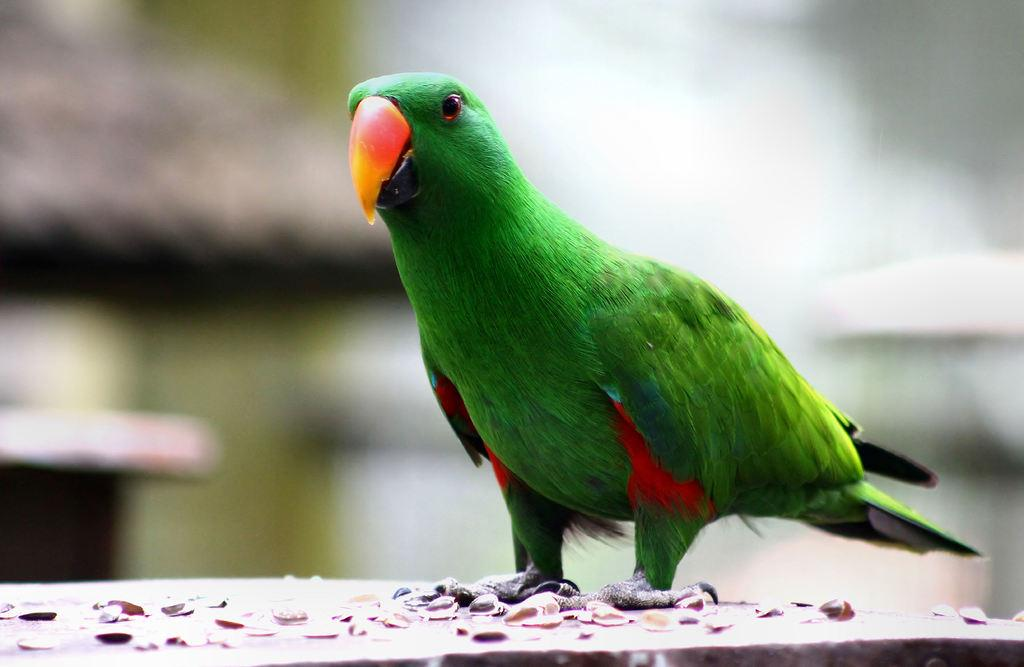What type of animal is in the image? There is a parrot in the image. Where is the parrot located? The parrot is on an object. What else can be seen on the object? There are items on the object. Can you describe the background of the image? The background of the image is blurred, but objects are visible in the background. What type of string is the parrot using to change the channel on the TV in the image? There is no TV or string present in the image, and the parrot is not shown interacting with any channel-changing device. 